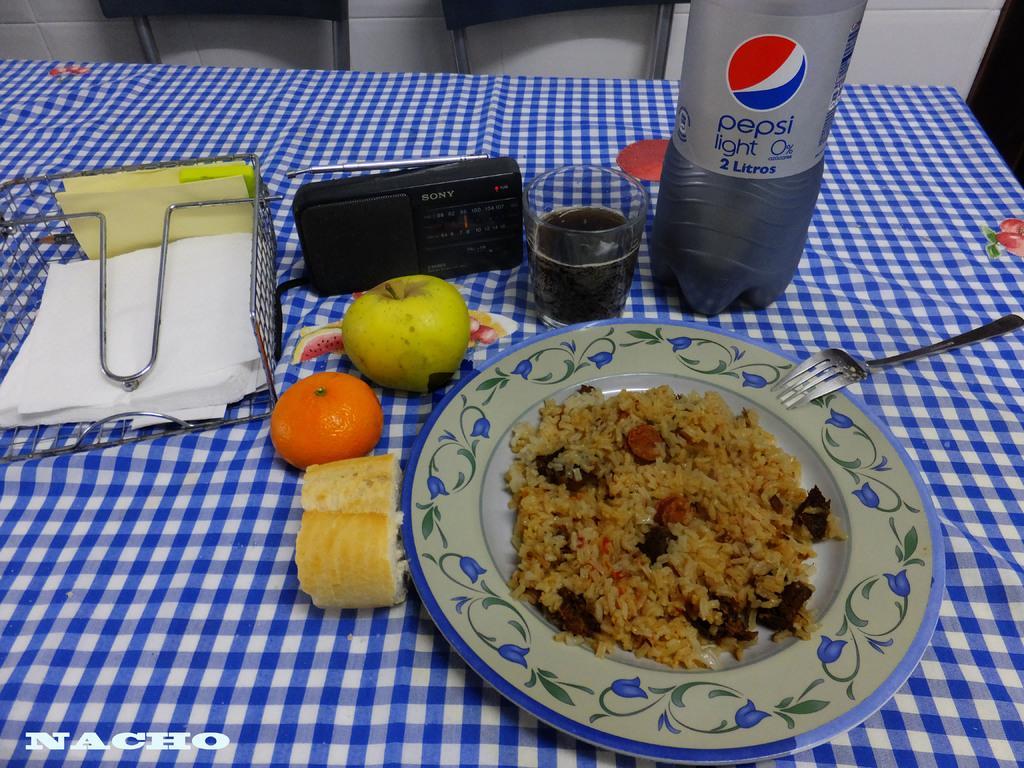Describe this image in one or two sentences. In this image we can see a table on which we can see a plate which contains food item, a fork, a bottle, a glass which contain drink, fruits and tissues. 